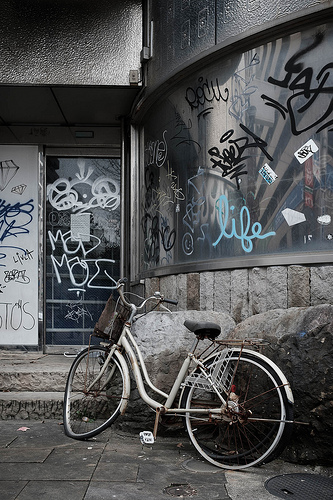<image>
Is there a bike under the rock? No. The bike is not positioned under the rock. The vertical relationship between these objects is different. 